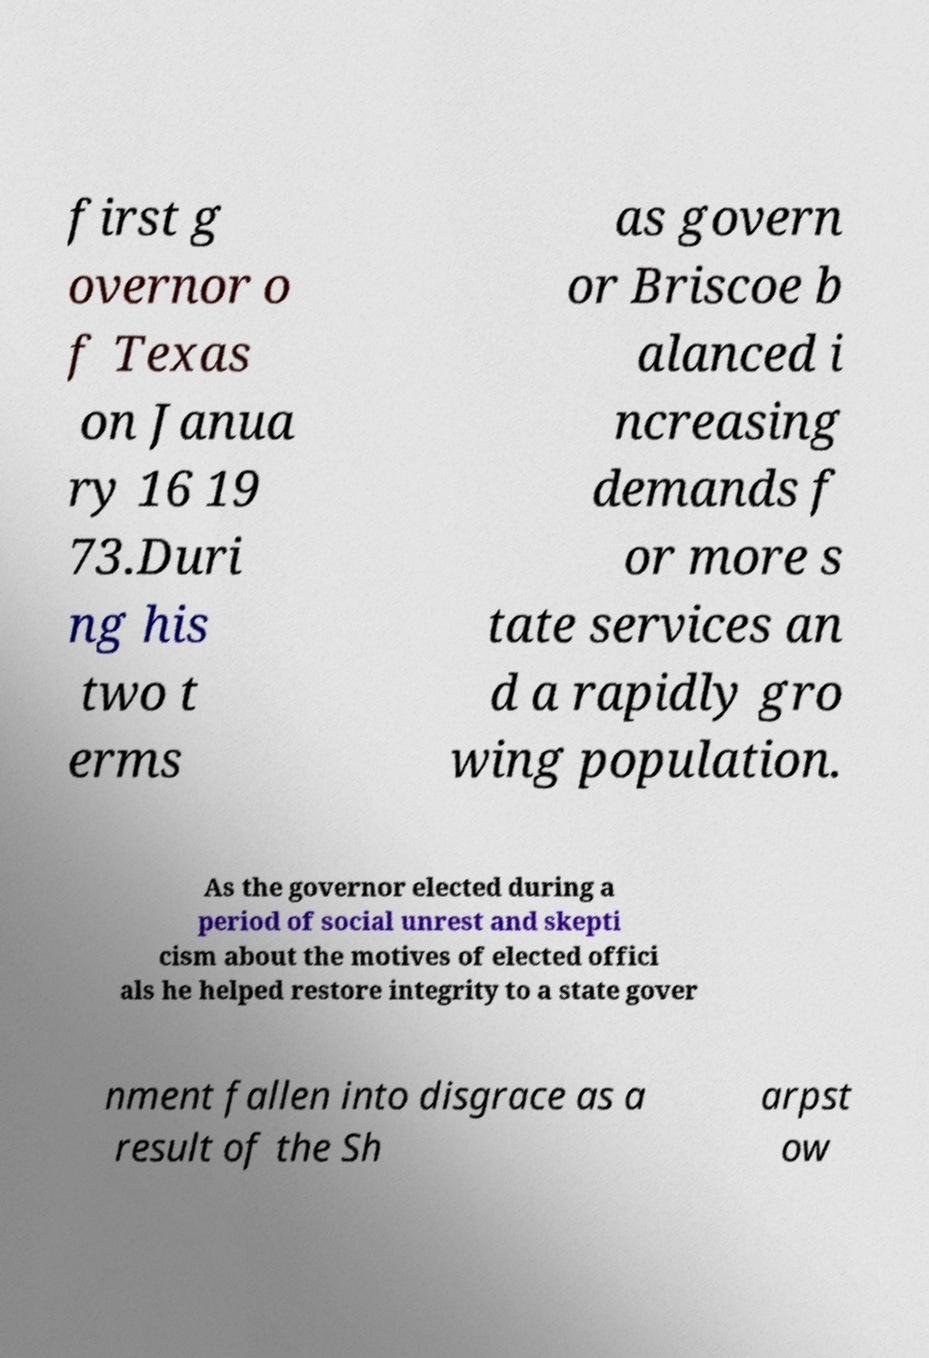Can you accurately transcribe the text from the provided image for me? first g overnor o f Texas on Janua ry 16 19 73.Duri ng his two t erms as govern or Briscoe b alanced i ncreasing demands f or more s tate services an d a rapidly gro wing population. As the governor elected during a period of social unrest and skepti cism about the motives of elected offici als he helped restore integrity to a state gover nment fallen into disgrace as a result of the Sh arpst ow 